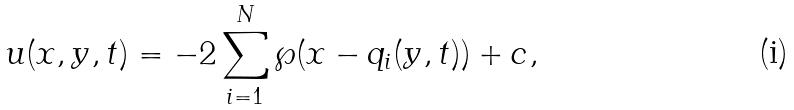Convert formula to latex. <formula><loc_0><loc_0><loc_500><loc_500>u ( x , y , t ) = - 2 \sum _ { i = 1 } ^ { N } \wp ( x - q _ { i } ( y , t ) ) + c ,</formula> 